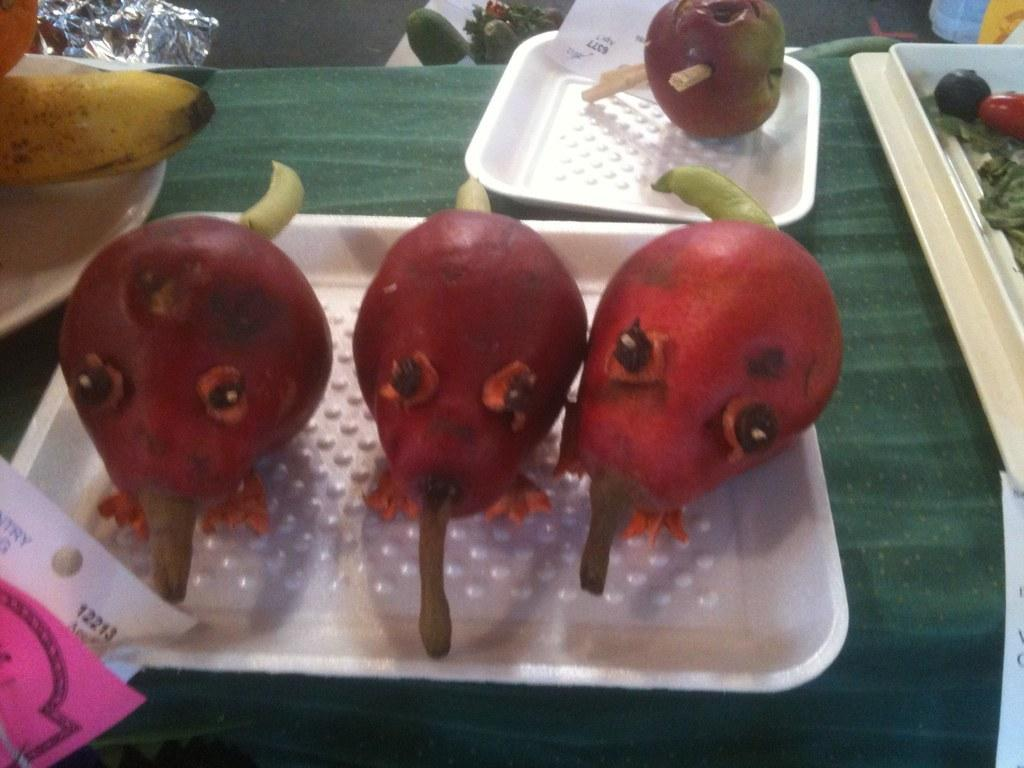What is the main piece of furniture in the image? There is a table in the image. What is covering the table? The table has a green cloth on it. What is placed on the green cloth? There are trays on the green cloth. What can be found inside the trays? The trays contain different fruits. Where are the papers located in the image? The papers are in the left corner of the image. What type of fog can be seen surrounding the boat in the image? There is no boat or fog present in the image; it features a table with trays of fruits and papers. 